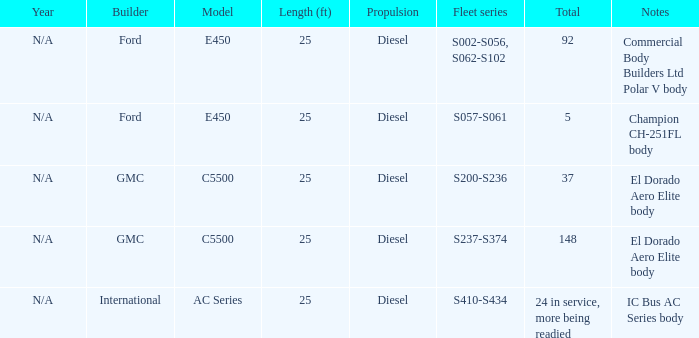How many international builders are there? 24 in service, more being readied. Could you parse the entire table as a dict? {'header': ['Year', 'Builder', 'Model', 'Length (ft)', 'Propulsion', 'Fleet series', 'Total', 'Notes'], 'rows': [['N/A', 'Ford', 'E450', '25', 'Diesel', 'S002-S056, S062-S102', '92', 'Commercial Body Builders Ltd Polar V body'], ['N/A', 'Ford', 'E450', '25', 'Diesel', 'S057-S061', '5', 'Champion CH-251FL body'], ['N/A', 'GMC', 'C5500', '25', 'Diesel', 'S200-S236', '37', 'El Dorado Aero Elite body'], ['N/A', 'GMC', 'C5500', '25', 'Diesel', 'S237-S374', '148', 'El Dorado Aero Elite body'], ['N/A', 'International', 'AC Series', '25', 'Diesel', 'S410-S434', '24 in service, more being readied', 'IC Bus AC Series body']]} 